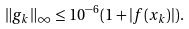<formula> <loc_0><loc_0><loc_500><loc_500>\| g _ { k } \| _ { \infty } \leq 1 0 ^ { - 6 } ( 1 + | f ( x _ { k } ) | ) .</formula> 